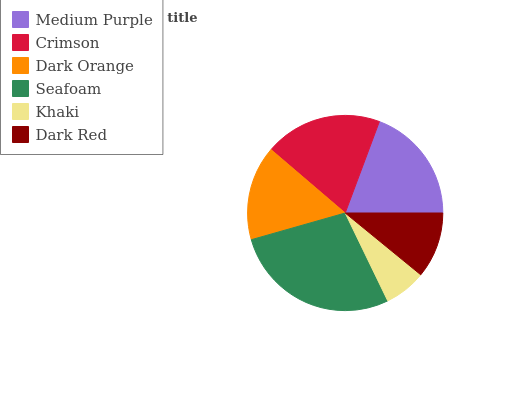Is Khaki the minimum?
Answer yes or no. Yes. Is Seafoam the maximum?
Answer yes or no. Yes. Is Crimson the minimum?
Answer yes or no. No. Is Crimson the maximum?
Answer yes or no. No. Is Crimson greater than Medium Purple?
Answer yes or no. Yes. Is Medium Purple less than Crimson?
Answer yes or no. Yes. Is Medium Purple greater than Crimson?
Answer yes or no. No. Is Crimson less than Medium Purple?
Answer yes or no. No. Is Medium Purple the high median?
Answer yes or no. Yes. Is Dark Orange the low median?
Answer yes or no. Yes. Is Dark Red the high median?
Answer yes or no. No. Is Crimson the low median?
Answer yes or no. No. 